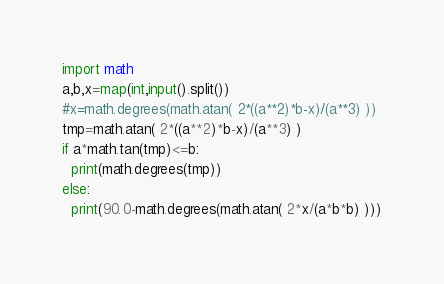Convert code to text. <code><loc_0><loc_0><loc_500><loc_500><_Python_>import math
a,b,x=map(int,input().split())
#x=math.degrees(math.atan( 2*((a**2)*b-x)/(a**3) ))
tmp=math.atan( 2*((a**2)*b-x)/(a**3) )
if a*math.tan(tmp)<=b:
  print(math.degrees(tmp))
else:
  print(90.0-math.degrees(math.atan( 2*x/(a*b*b) )))</code> 